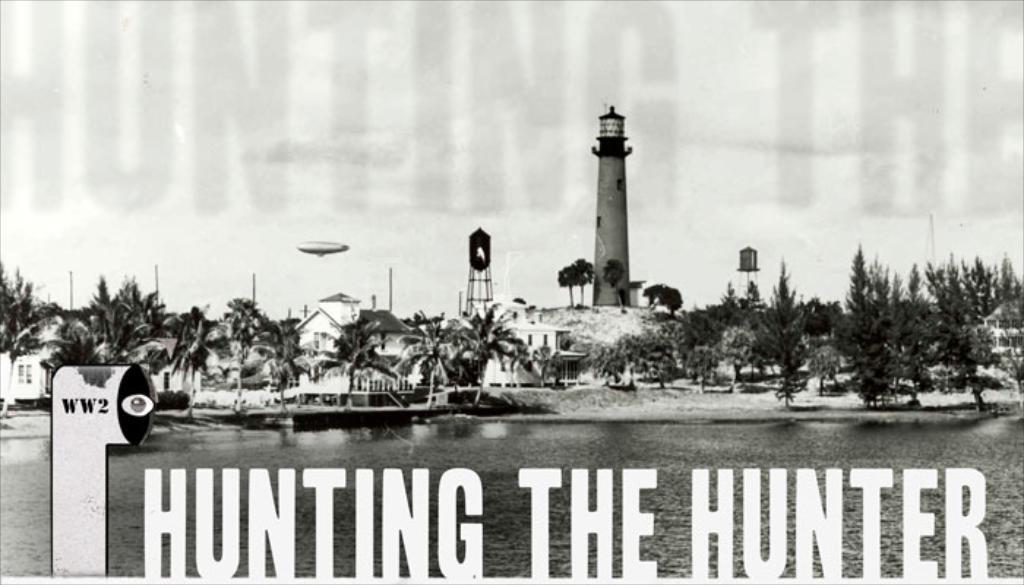How would you summarize this image in a sentence or two? In this picture we can see a boat on water and in the background we can see buildings, towers, trees and sky, at the bottom we can see some text. 